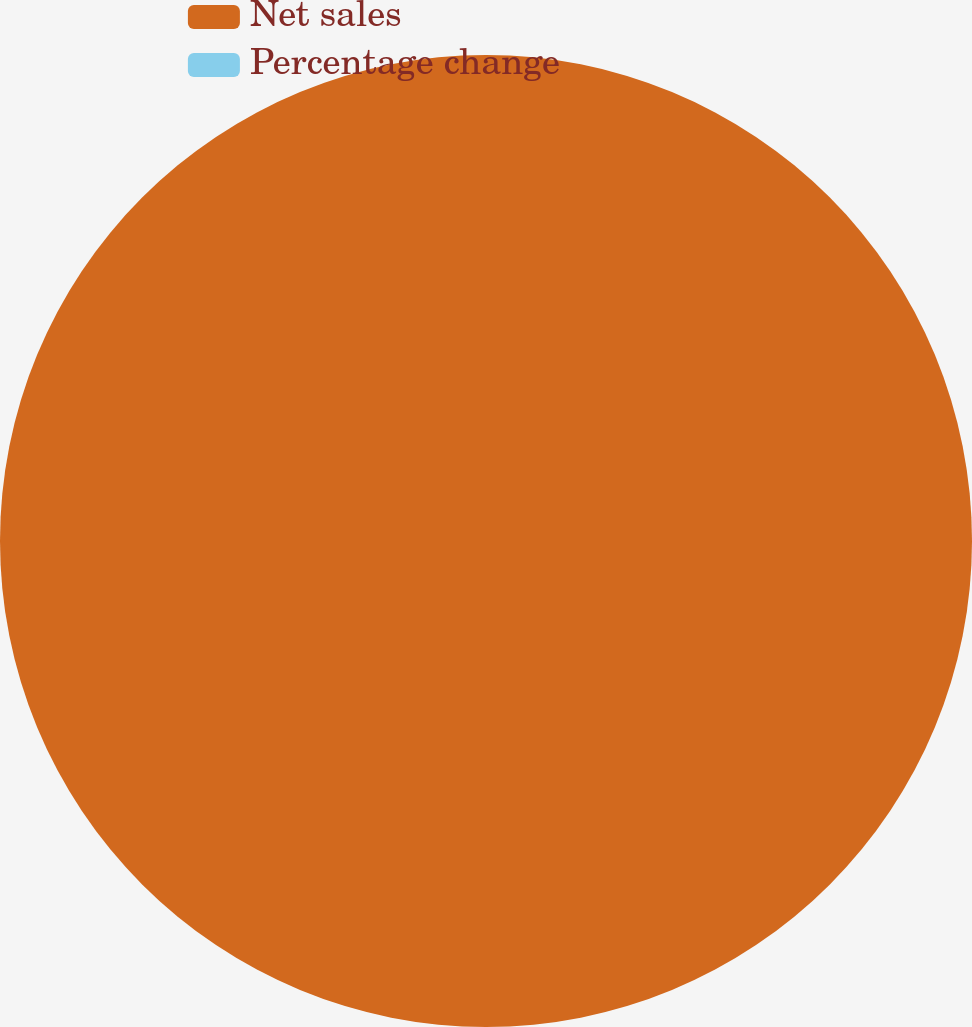Convert chart to OTSL. <chart><loc_0><loc_0><loc_500><loc_500><pie_chart><fcel>Net sales<fcel>Percentage change<nl><fcel>100.0%<fcel>0.0%<nl></chart> 